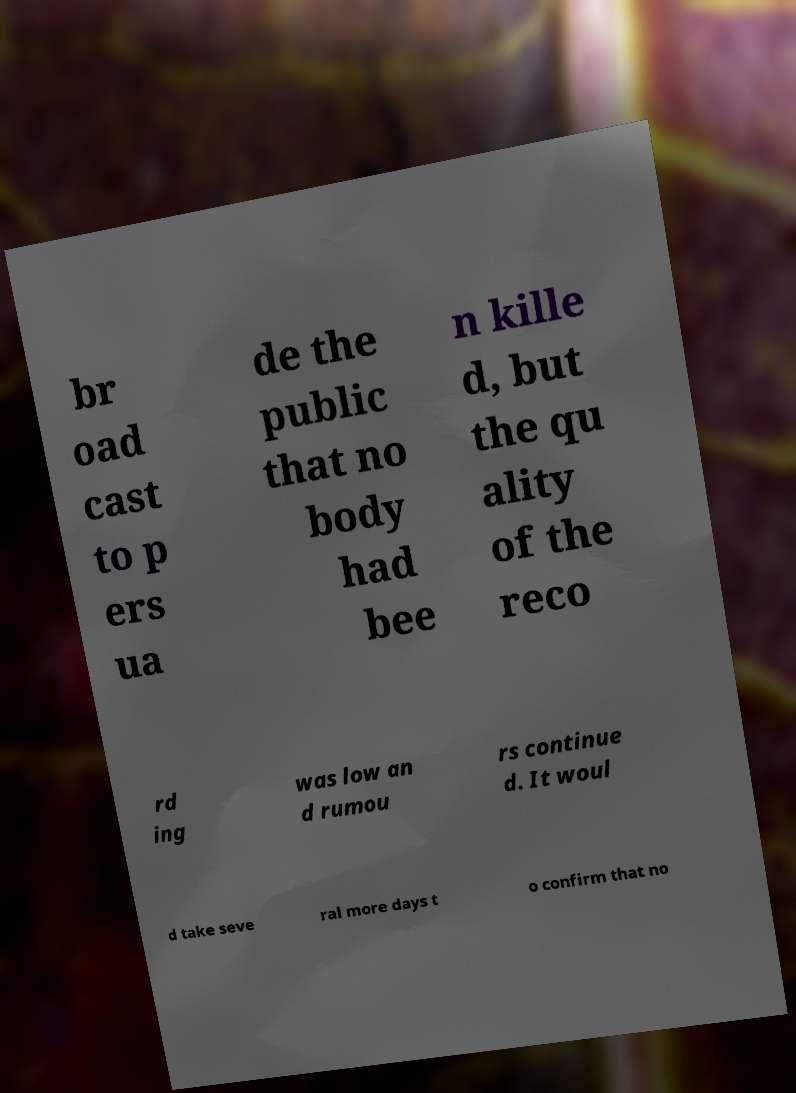For documentation purposes, I need the text within this image transcribed. Could you provide that? br oad cast to p ers ua de the public that no body had bee n kille d, but the qu ality of the reco rd ing was low an d rumou rs continue d. It woul d take seve ral more days t o confirm that no 